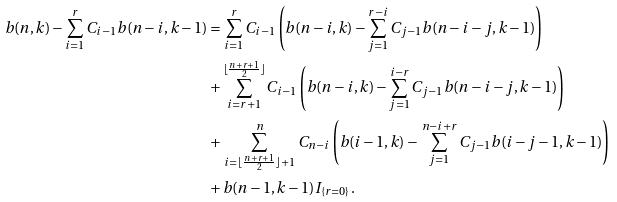Convert formula to latex. <formula><loc_0><loc_0><loc_500><loc_500>b ( n , k ) - \sum _ { i = 1 } ^ { r } C _ { i - 1 } b ( n - i , k - 1 ) & = \sum _ { i = 1 } ^ { r } C _ { i - 1 } \left ( b ( n - i , k ) - \sum _ { j = 1 } ^ { r - i } C _ { j - 1 } b ( n - i - j , k - 1 ) \right ) \\ & + \sum _ { i = r + 1 } ^ { \lfloor \frac { n + r + 1 } { 2 } \rfloor } C _ { i - 1 } \left ( b ( n - i , k ) - \sum _ { j = 1 } ^ { i - r } C _ { j - 1 } b ( n - i - j , k - 1 ) \right ) \\ & + \, \sum _ { i = \lfloor \frac { n + r + 1 } { 2 } \rfloor + 1 } ^ { n } \, C _ { n - i } \left ( b ( i - 1 , k ) - \, \sum _ { j = 1 } ^ { n - i + r } C _ { j - 1 } b ( i - j - 1 , k - 1 ) \right ) \\ & + b ( n - 1 , k - 1 ) I _ { \{ r = 0 \} } .</formula> 